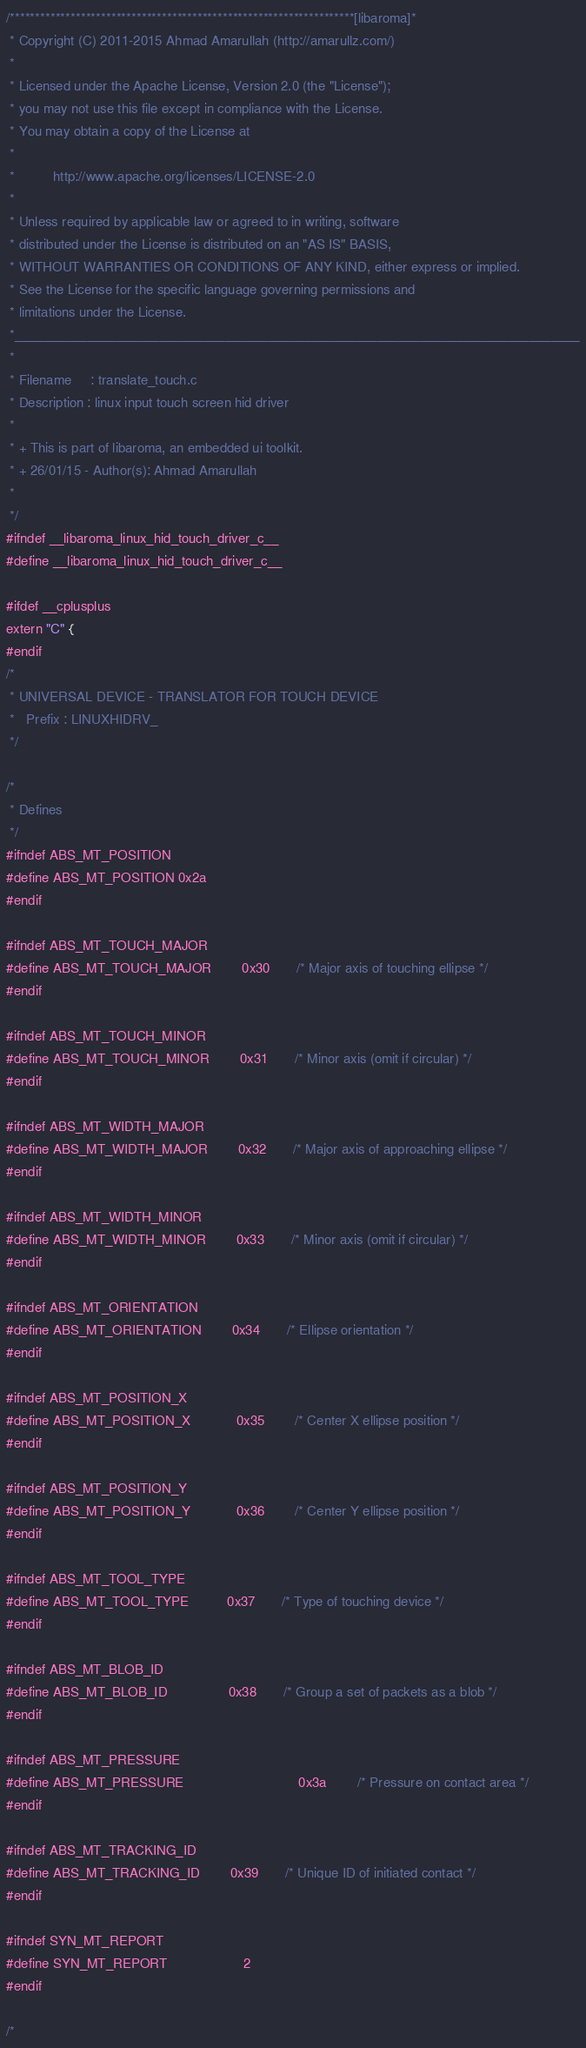Convert code to text. <code><loc_0><loc_0><loc_500><loc_500><_C_>/********************************************************************[libaroma]*
 * Copyright (C) 2011-2015 Ahmad Amarullah (http://amarullz.com/)
 *
 * Licensed under the Apache License, Version 2.0 (the "License");
 * you may not use this file except in compliance with the License.
 * You may obtain a copy of the License at
 *
 *			http://www.apache.org/licenses/LICENSE-2.0
 *
 * Unless required by applicable law or agreed to in writing, software
 * distributed under the License is distributed on an "AS IS" BASIS,
 * WITHOUT WARRANTIES OR CONDITIONS OF ANY KIND, either express or implied.
 * See the License for the specific language governing permissions and
 * limitations under the License.
 *______________________________________________________________________________
 *
 * Filename		: translate_touch.c
 * Description : linux input touch screen hid driver
 *
 * + This is part of libaroma, an embedded ui toolkit.
 * + 26/01/15 - Author(s): Ahmad Amarullah
 *
 */
#ifndef __libaroma_linux_hid_touch_driver_c__
#define __libaroma_linux_hid_touch_driver_c__

#ifdef __cplusplus
extern "C" {
#endif
/*
 * UNIVERSAL DEVICE - TRANSLATOR FOR TOUCH DEVICE
 *	 Prefix : LINUXHIDRV_
 */

/*
 * Defines
 */
#ifndef ABS_MT_POSITION
#define ABS_MT_POSITION 0x2a
#endif

#ifndef ABS_MT_TOUCH_MAJOR
#define ABS_MT_TOUCH_MAJOR		 0x30		/* Major axis of touching ellipse */
#endif

#ifndef ABS_MT_TOUCH_MINOR
#define ABS_MT_TOUCH_MINOR		 0x31		/* Minor axis (omit if circular) */
#endif

#ifndef ABS_MT_WIDTH_MAJOR
#define ABS_MT_WIDTH_MAJOR		 0x32		/* Major axis of approaching ellipse */
#endif

#ifndef ABS_MT_WIDTH_MINOR
#define ABS_MT_WIDTH_MINOR		 0x33		/* Minor axis (omit if circular) */
#endif

#ifndef ABS_MT_ORIENTATION
#define ABS_MT_ORIENTATION		 0x34		/* Ellipse orientation */
#endif

#ifndef ABS_MT_POSITION_X
#define ABS_MT_POSITION_X			0x35		/* Center X ellipse position */
#endif

#ifndef ABS_MT_POSITION_Y
#define ABS_MT_POSITION_Y			0x36		/* Center Y ellipse position */
#endif

#ifndef ABS_MT_TOOL_TYPE
#define ABS_MT_TOOL_TYPE			 0x37		/* Type of touching device */
#endif

#ifndef ABS_MT_BLOB_ID
#define ABS_MT_BLOB_ID				 0x38		/* Group a set of packets as a blob */
#endif

#ifndef ABS_MT_PRESSURE
#define ABS_MT_PRESSURE								0x3a		/* Pressure on contact area */
#endif

#ifndef ABS_MT_TRACKING_ID
#define ABS_MT_TRACKING_ID		 0x39		/* Unique ID of initiated contact */
#endif

#ifndef SYN_MT_REPORT
#define SYN_MT_REPORT					2
#endif

/*</code> 